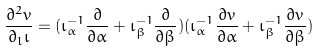Convert formula to latex. <formula><loc_0><loc_0><loc_500><loc_500>\frac { \partial ^ { 2 } v } { \partial _ { l } \iota } = ( { \iota } _ { \alpha } ^ { - 1 } \frac { \partial } { \partial \alpha } + { \iota } _ { \beta } ^ { - 1 } \frac { \partial } { \partial \beta } ) ( { \iota } _ { \alpha } ^ { - 1 } \frac { \partial v } { \partial \alpha } + { \iota } _ { \beta } ^ { - 1 } \frac { \partial v } { \partial \beta } )</formula> 